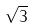Convert formula to latex. <formula><loc_0><loc_0><loc_500><loc_500>\sqrt { 3 }</formula> 